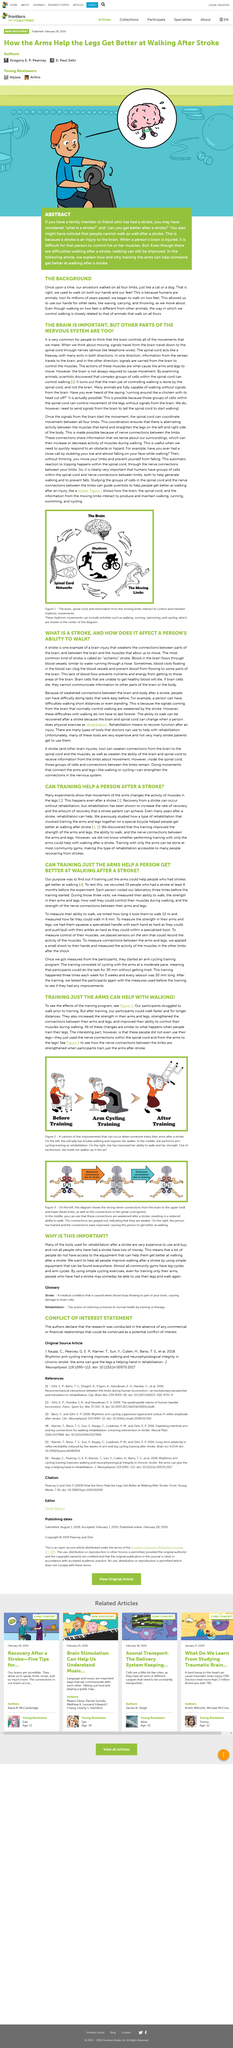Point out several critical features in this image. They recruited a total of 19 people. Stroke is a type of brain injury that impairs the connectivity between different parts of the brain and between the brain and muscles, resulting in reduced mobility and strength. After completing the training program, the participants experienced an increase in the strength of their arms and legs, as well as the strengthened connections between their arms and legs. Additionally, their ability to control their muscles during workouts improved significantly. The most common type of stroke is known as an ischemic stroke. The author mentions that the spinal chord is another part of the nervous system that is important, in addition to the brain and peripheral nervous system mentioned in the passage. 